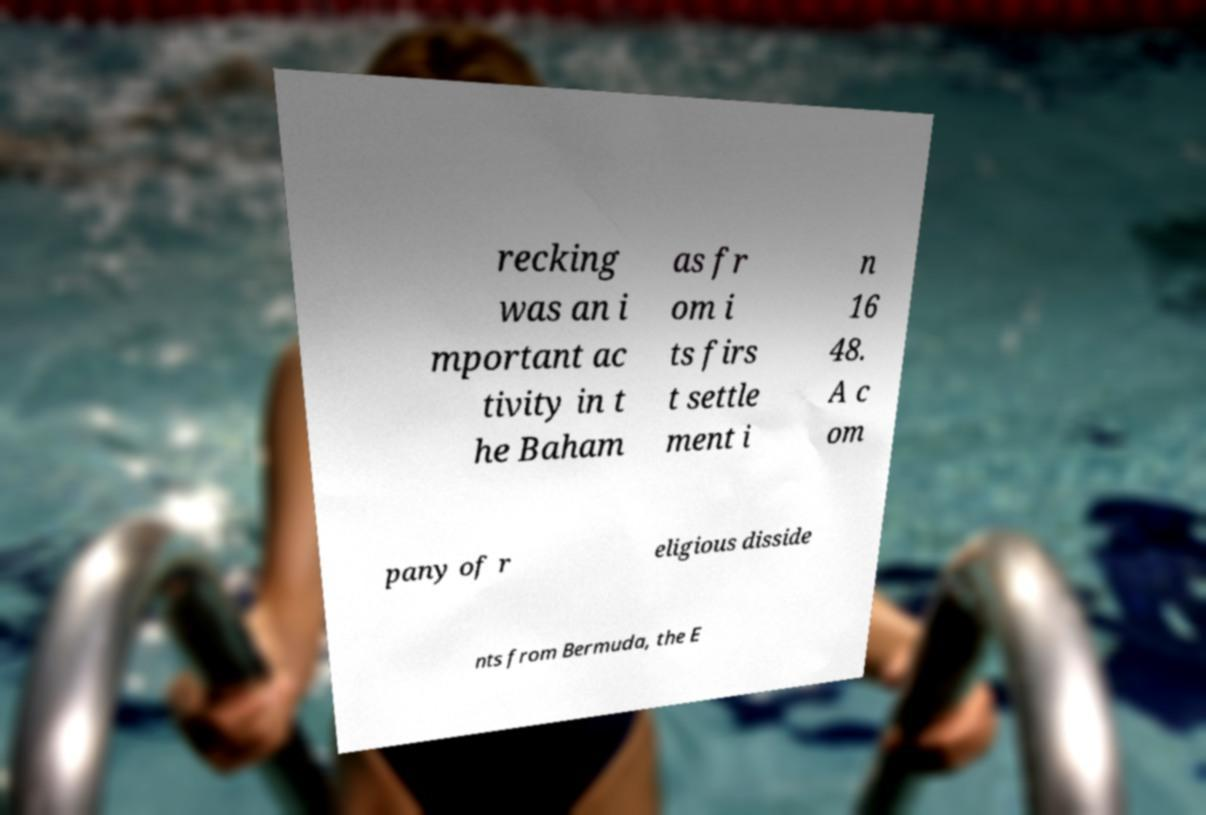Can you accurately transcribe the text from the provided image for me? recking was an i mportant ac tivity in t he Baham as fr om i ts firs t settle ment i n 16 48. A c om pany of r eligious disside nts from Bermuda, the E 